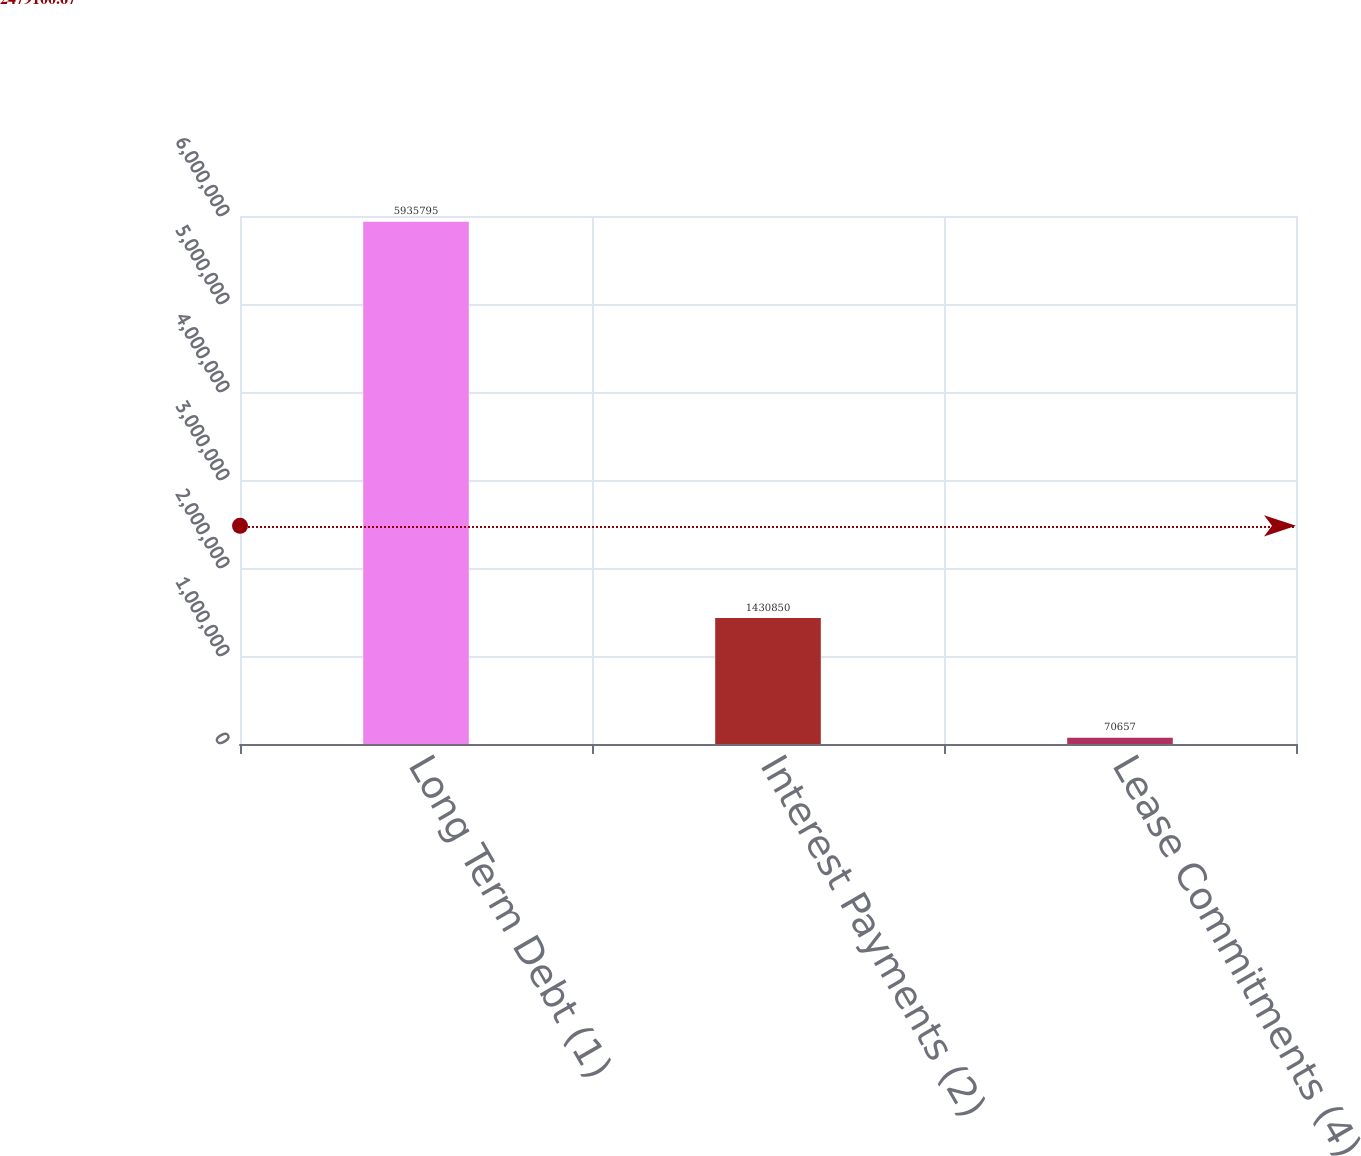Convert chart to OTSL. <chart><loc_0><loc_0><loc_500><loc_500><bar_chart><fcel>Long Term Debt (1)<fcel>Interest Payments (2)<fcel>Lease Commitments (4)<nl><fcel>5.9358e+06<fcel>1.43085e+06<fcel>70657<nl></chart> 